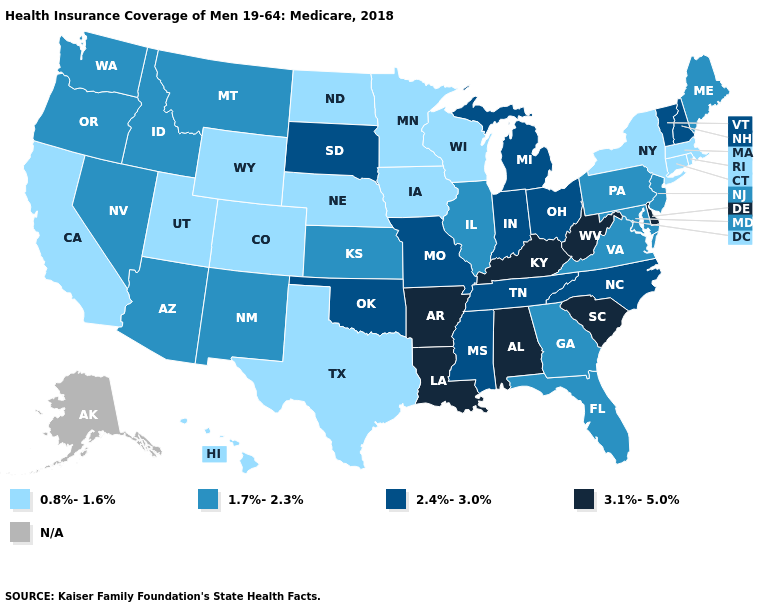What is the value of Illinois?
Concise answer only. 1.7%-2.3%. Which states have the lowest value in the USA?
Write a very short answer. California, Colorado, Connecticut, Hawaii, Iowa, Massachusetts, Minnesota, Nebraska, New York, North Dakota, Rhode Island, Texas, Utah, Wisconsin, Wyoming. Does Delaware have the highest value in the USA?
Short answer required. Yes. Does the first symbol in the legend represent the smallest category?
Write a very short answer. Yes. Among the states that border Missouri , which have the lowest value?
Keep it brief. Iowa, Nebraska. Among the states that border Kansas , which have the lowest value?
Answer briefly. Colorado, Nebraska. What is the highest value in states that border Ohio?
Write a very short answer. 3.1%-5.0%. Does Vermont have the highest value in the Northeast?
Concise answer only. Yes. How many symbols are there in the legend?
Give a very brief answer. 5. Which states have the highest value in the USA?
Write a very short answer. Alabama, Arkansas, Delaware, Kentucky, Louisiana, South Carolina, West Virginia. Which states have the lowest value in the USA?
Be succinct. California, Colorado, Connecticut, Hawaii, Iowa, Massachusetts, Minnesota, Nebraska, New York, North Dakota, Rhode Island, Texas, Utah, Wisconsin, Wyoming. What is the value of Wyoming?
Write a very short answer. 0.8%-1.6%. Among the states that border Iowa , which have the lowest value?
Short answer required. Minnesota, Nebraska, Wisconsin. Name the states that have a value in the range 2.4%-3.0%?
Concise answer only. Indiana, Michigan, Mississippi, Missouri, New Hampshire, North Carolina, Ohio, Oklahoma, South Dakota, Tennessee, Vermont. What is the highest value in the South ?
Keep it brief. 3.1%-5.0%. 